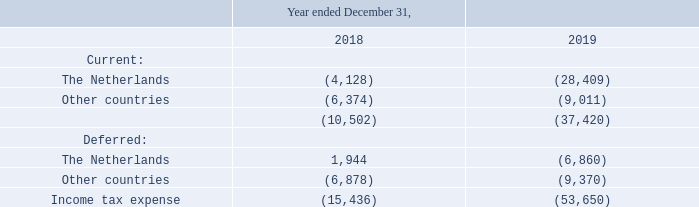NOTE 22. INCOME TAXES
Amounts recognized in profit or loss
The income tax expense consists of:
What does the table show? The income tax expense. What is the total current income tax expense for 2019? (37,420). What is the current income tax expense for The Netherlands in 2018 and 2019 respectively? (4,128), (28,409). What is the percentage change in total Income tax expense from 2018 to 2019?
Answer scale should be: percent. (-53,650-(-15,436))/-15,436
Answer: 247.56. What is the Current income tax expense for The Netherlands expressed as a percentage of Total income tax expense?
Answer scale should be: percent. -28,409/-53,650
Answer: 52.95. What is the change in total Current income tax expense from 2018 to 2019? -37,420-(-10,502)
Answer: -26918. 